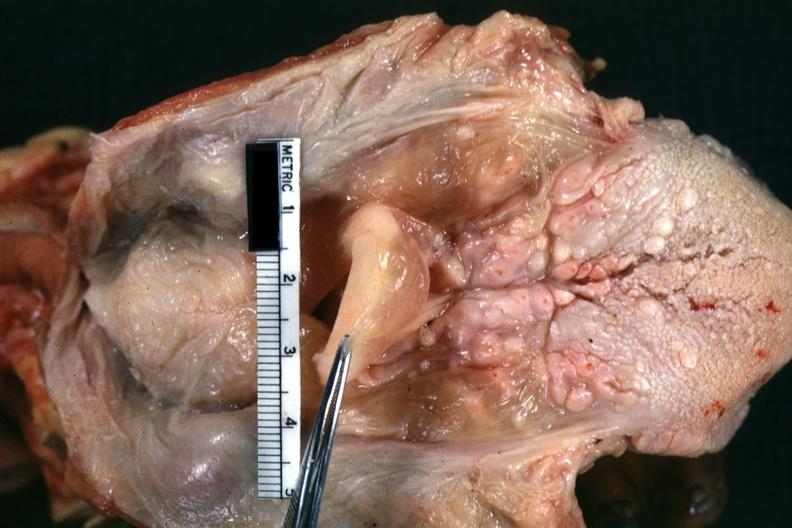where is this?
Answer the question using a single word or phrase. Oral 